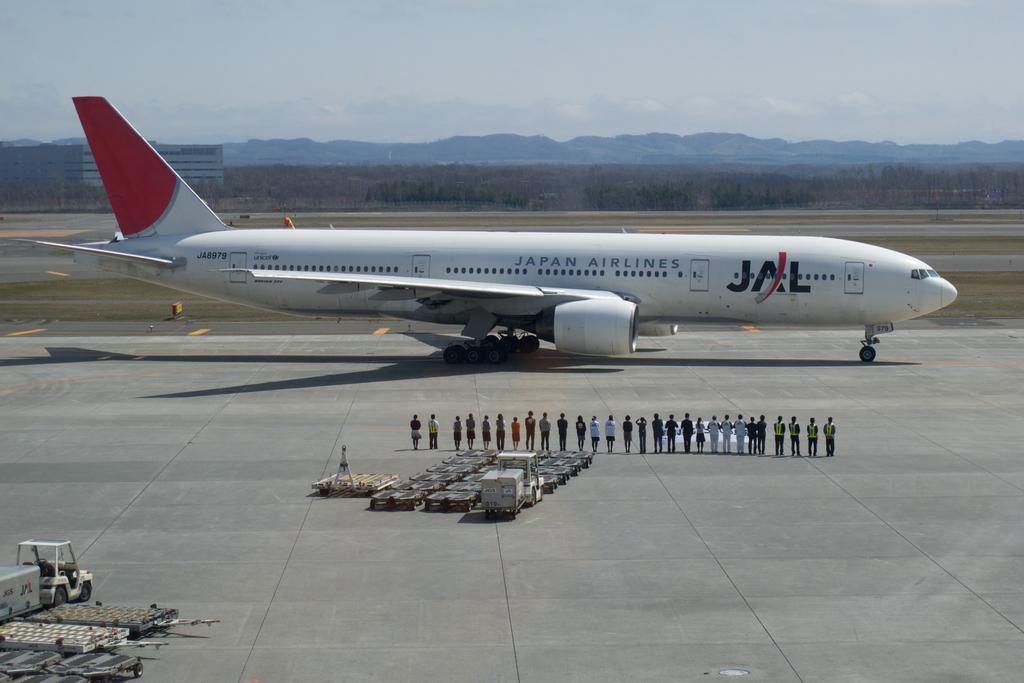Describe this image in one or two sentences. In this picture, we see the airplane in white and red color is on the runway. Beside that, we see the people are standing. Behind them, we see the vehicle and trolleys for luggage carts. In the left bottom, we see a vehicle and the carts. There are trees, buildings and trees in the background. At the top, we see the sky. 